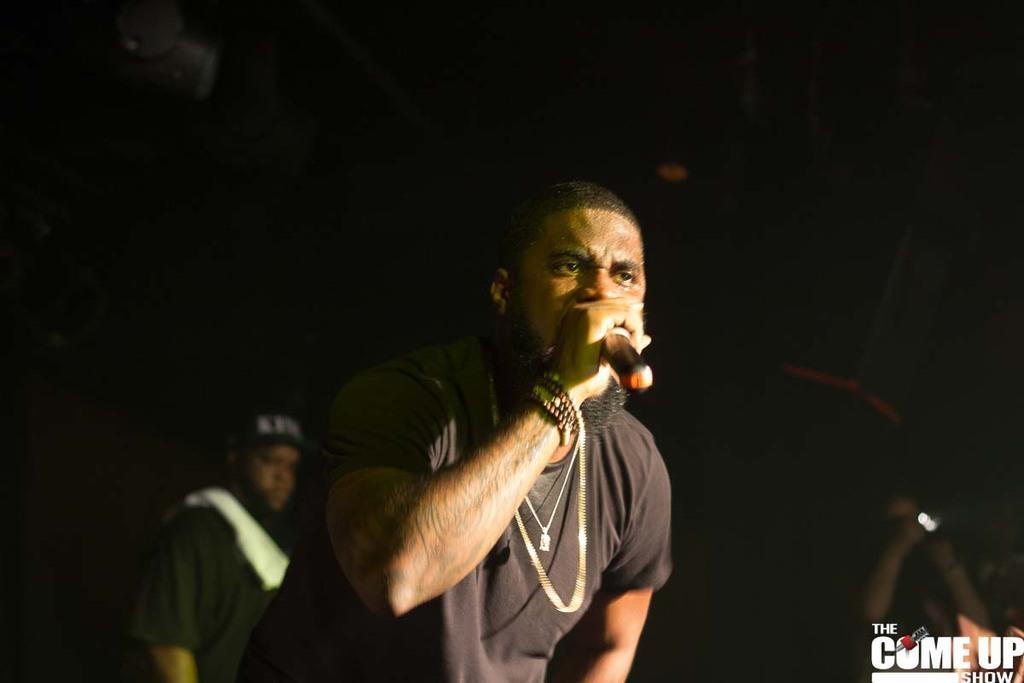Could you give a brief overview of what you see in this image? In this image I can see a person holding the mic. In the background there is another person wearing the cap. 